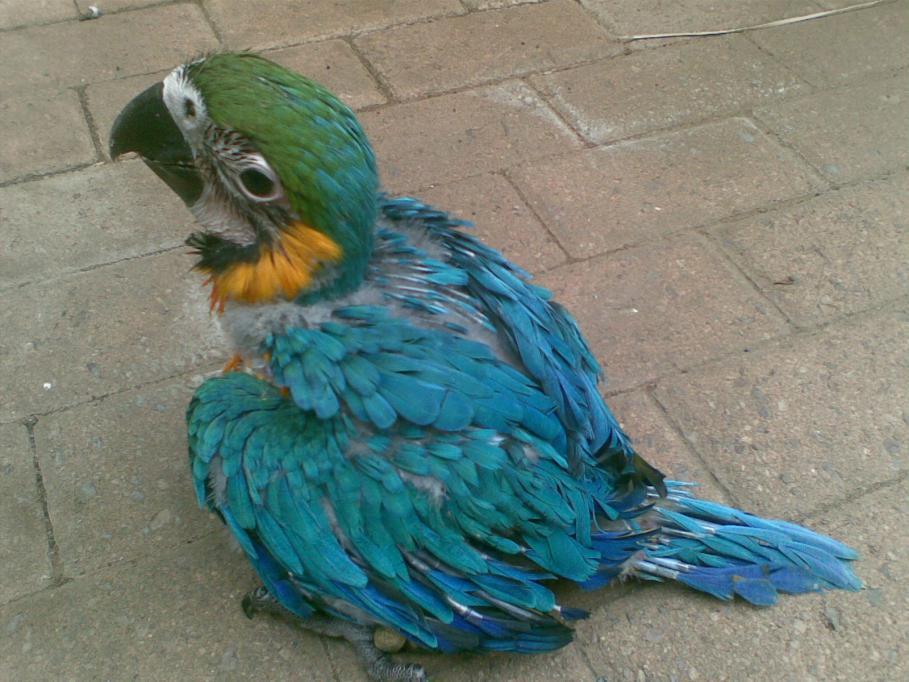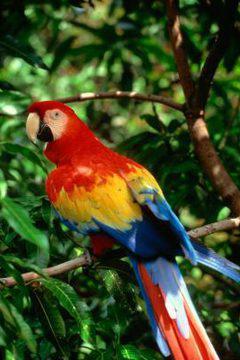The first image is the image on the left, the second image is the image on the right. Evaluate the accuracy of this statement regarding the images: "On one image, there's a parrot perched on a branch.". Is it true? Answer yes or no. Yes. The first image is the image on the left, the second image is the image on the right. For the images shown, is this caption "The birds in both images have predominantly blue and yellow coloring" true? Answer yes or no. No. 